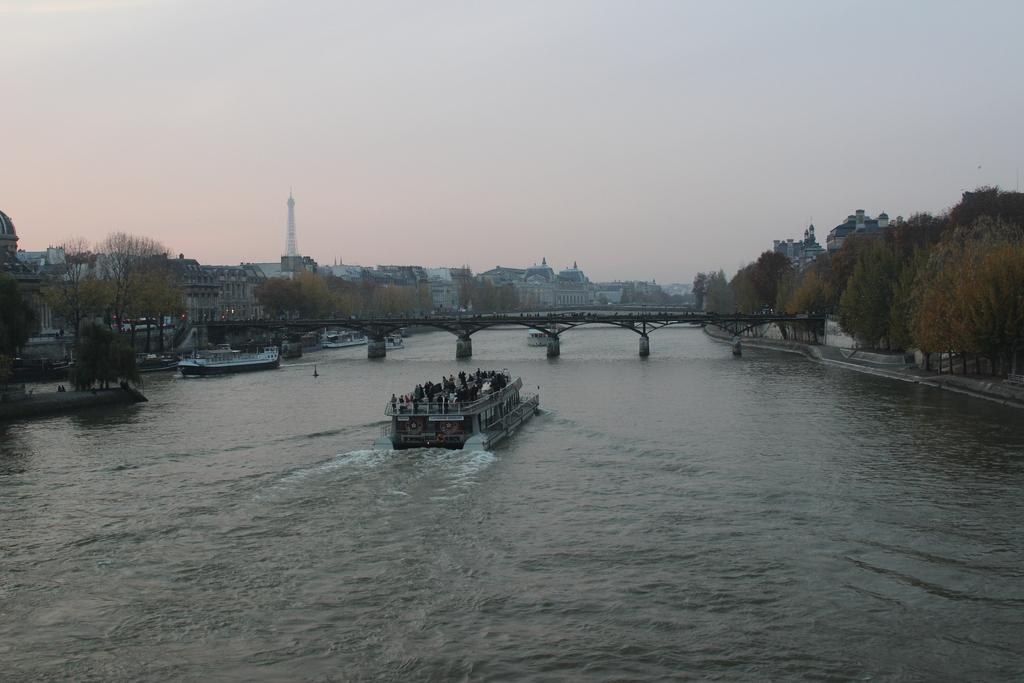What is the main subject in the foreground of the image? There is a boat in the foreground of the image. What is the boat's location in relation to the water? The boat is on the water. What can be seen in the background of the image? There are trees, a bridge, another ship, buildings, a tower, and the sky visible in the background of the image. What type of wrench is being used to fix the lamp on the bridge in the image? There is no wrench or lamp present on the bridge in the image. 